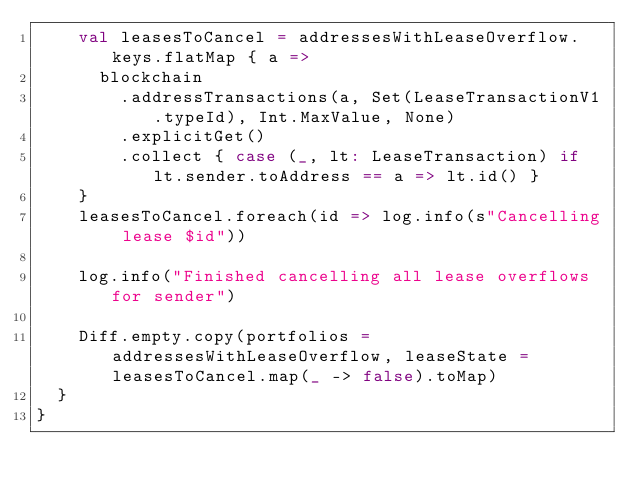Convert code to text. <code><loc_0><loc_0><loc_500><loc_500><_Scala_>    val leasesToCancel = addressesWithLeaseOverflow.keys.flatMap { a =>
      blockchain
        .addressTransactions(a, Set(LeaseTransactionV1.typeId), Int.MaxValue, None)
        .explicitGet()
        .collect { case (_, lt: LeaseTransaction) if lt.sender.toAddress == a => lt.id() }
    }
    leasesToCancel.foreach(id => log.info(s"Cancelling lease $id"))

    log.info("Finished cancelling all lease overflows for sender")

    Diff.empty.copy(portfolios = addressesWithLeaseOverflow, leaseState = leasesToCancel.map(_ -> false).toMap)
  }
}
</code> 